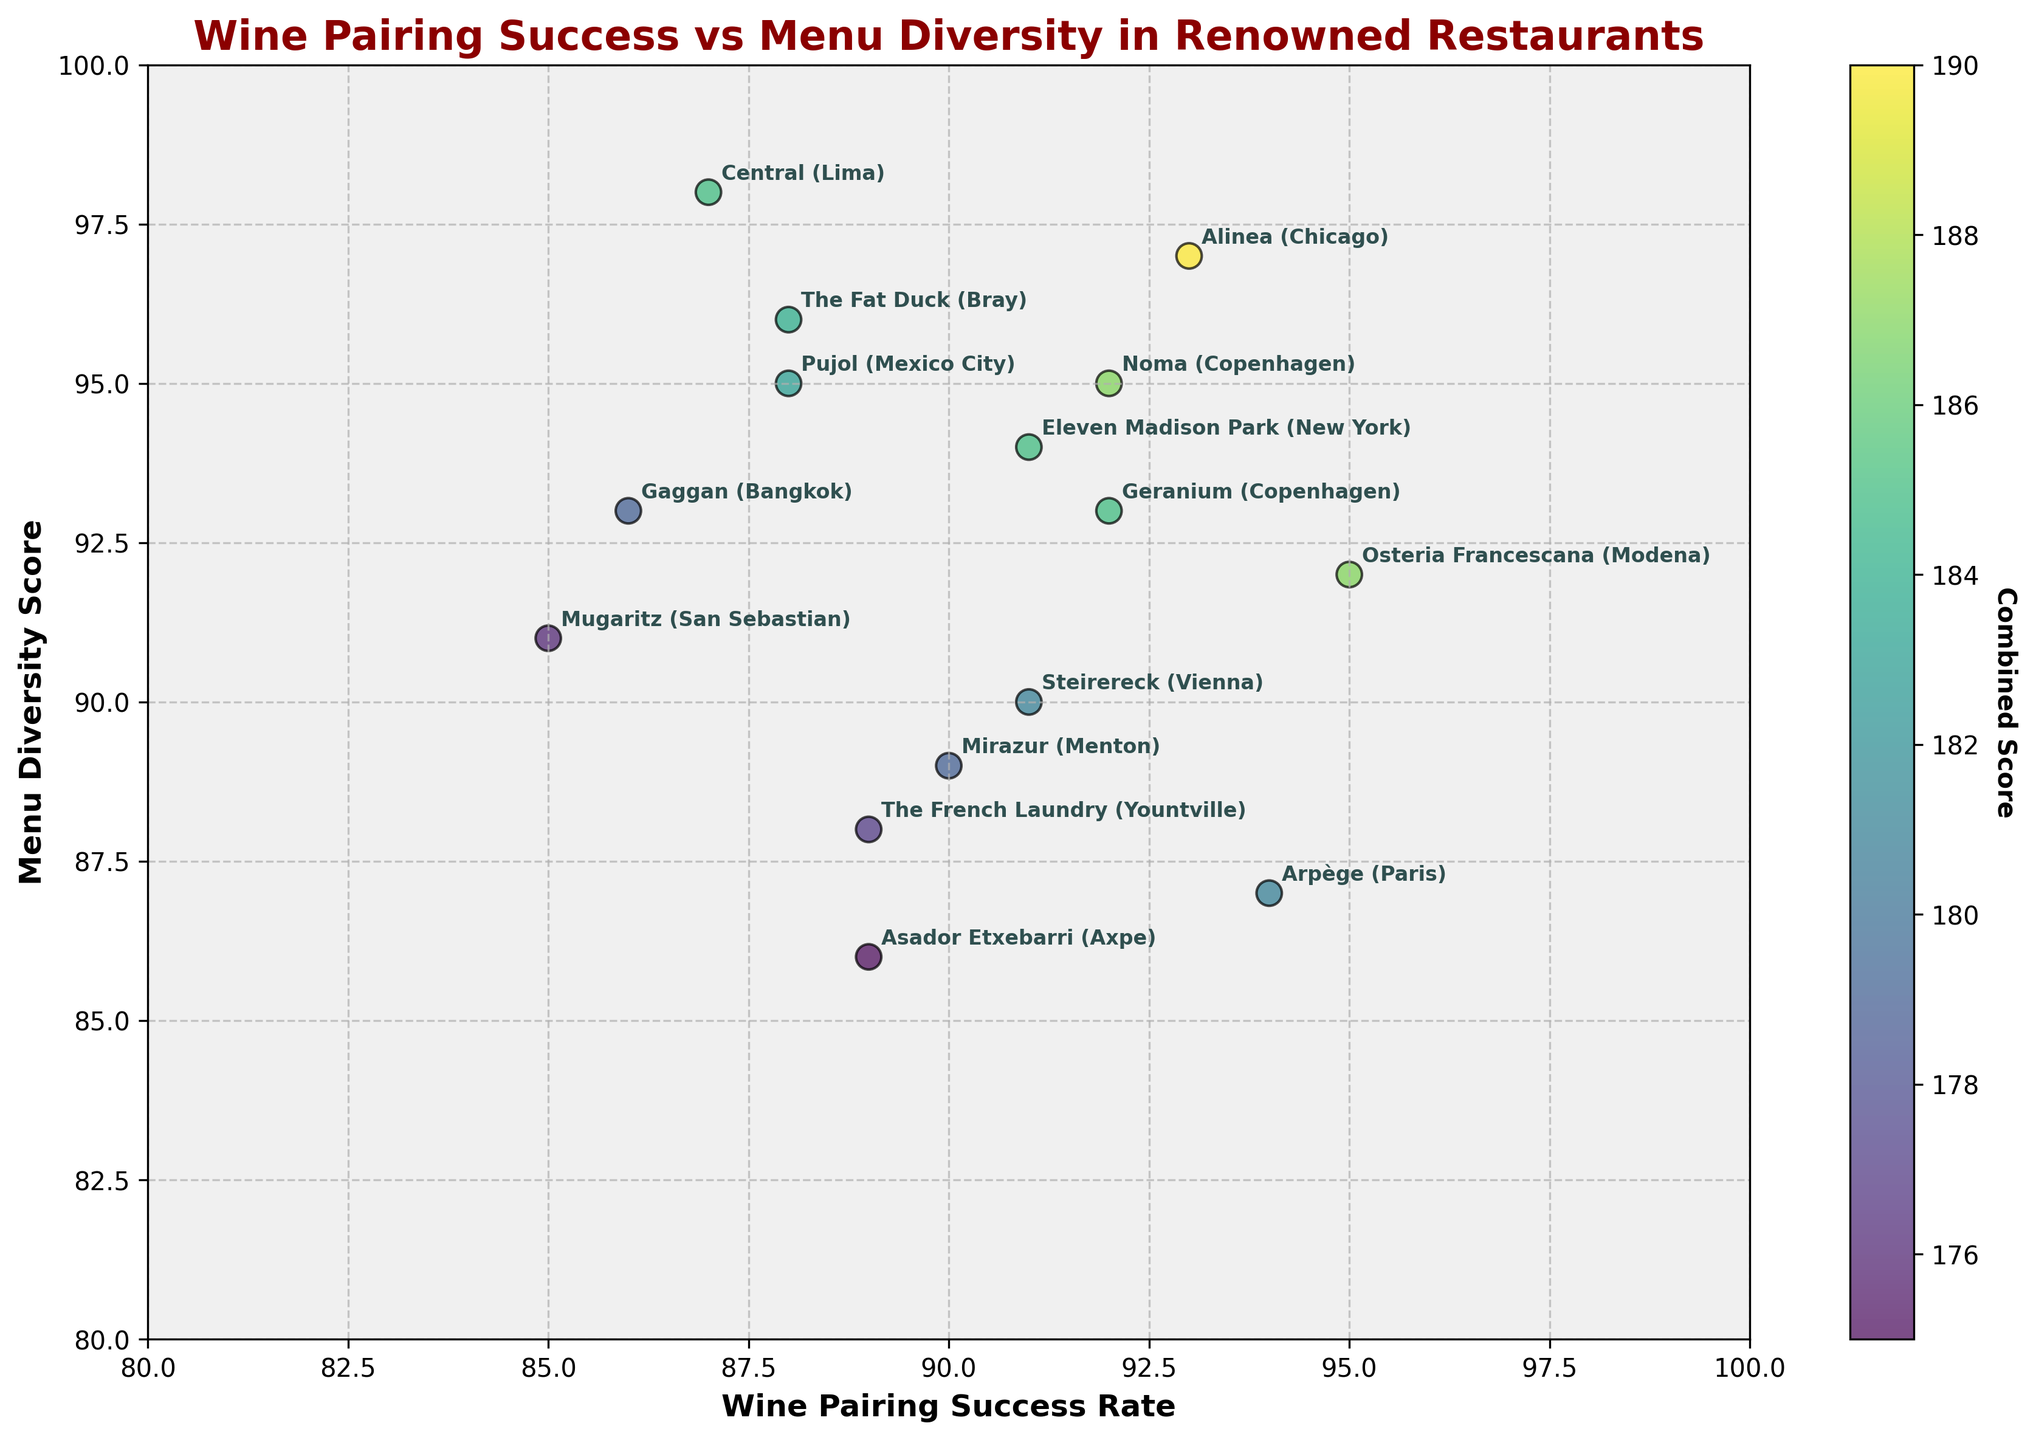Which restaurant has the highest wine pairing success rate? To find the highest wine pairing success rate, look for the highest position on the x-axis. Osteria Francescana stands out with a wine pairing success rate of 95.
Answer: Osteria Francescana Which restaurant has the lowest menu diversity score? Check the y-axis to find the restaurant with the lowest score. Asador Etxebarri has the lowest menu diversity score of 86.
Answer: Asador Etxebarri What is the combined score for Alinea, and is it the highest? Alinea's combined score is calculated by adding its wine pairing success rate (93) and menu diversity score (97), which totals 190. Yes, it is the highest combined score in the plot.
Answer: Yes, 190 How many restaurants have a menu diversity score of 90 or higher? Count the number of data points on or above the 90 mark on the y-axis. There are 11 restaurants with a menu diversity score of 90 or higher.
Answer: 11 Which restaurant is closest to having equal wine pairing success and menu diversity scores? Look for the point closest to the line y = x where wine pairing success rate equals menu diversity score. Noma has almost equal scores of 92 for wine pairing and 95 for menu diversity.
Answer: Noma Do more restaurants have a higher menu diversity score than wine pairing success rate? Compare the x and y values of each point to check if the y (menu diversity) is greater than x (wine pairing success). Yes, the majority of restaurants have higher menu diversity scores than wine pairing success rates.
Answer: Yes Which restaurant in Paris is included in the plot and what is its wine pairing success rate? Find the restaurant labeled "Paris". Arpège is in Paris with a wine pairing success rate of 94.
Answer: Arpège, 94 Is there any restaurant with a combined score less than 170? Add the x and y values of each point. If the sum is less than 170, it meets the condition. Mugaritz has a combined score of 85 (wine pairing) + 91 (menu diversity) = 176, which is the closest but not less than 170.
Answer: No 